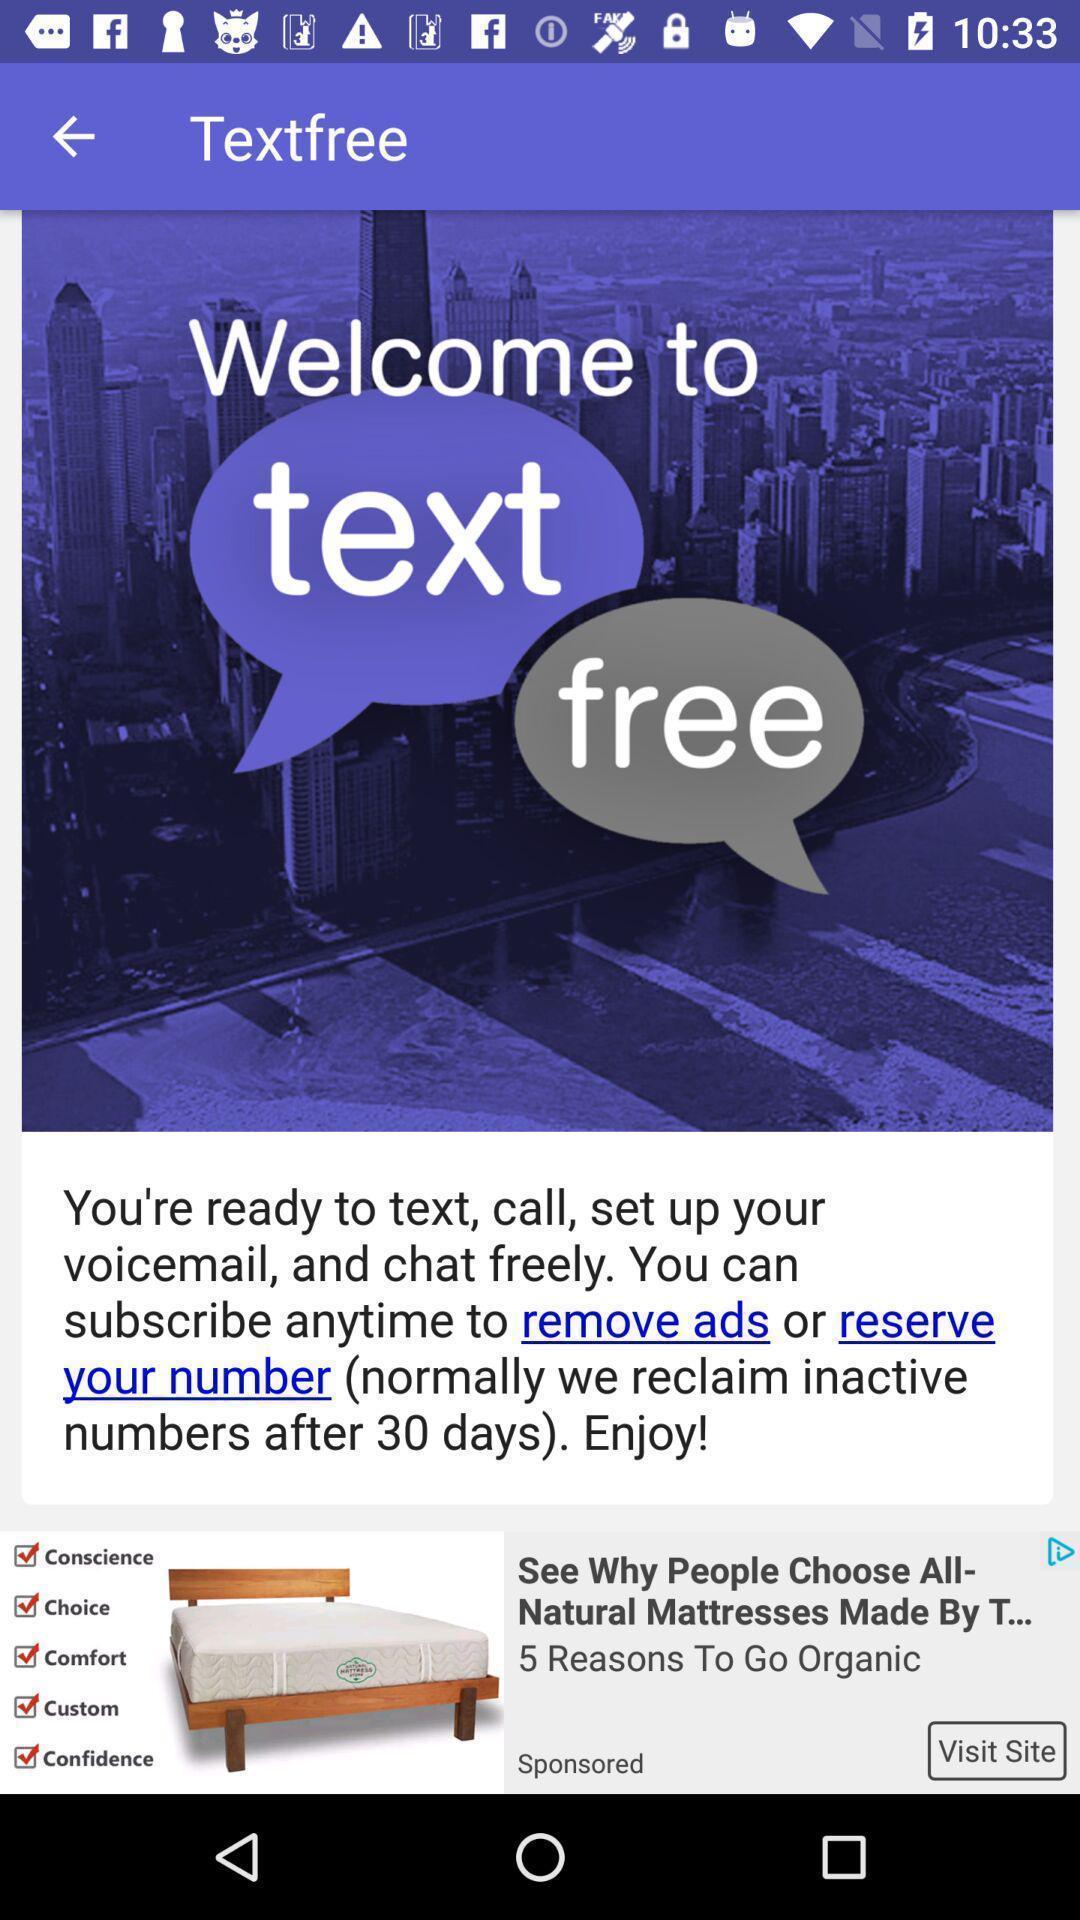Summarize the main components in this picture. Welcome page. 